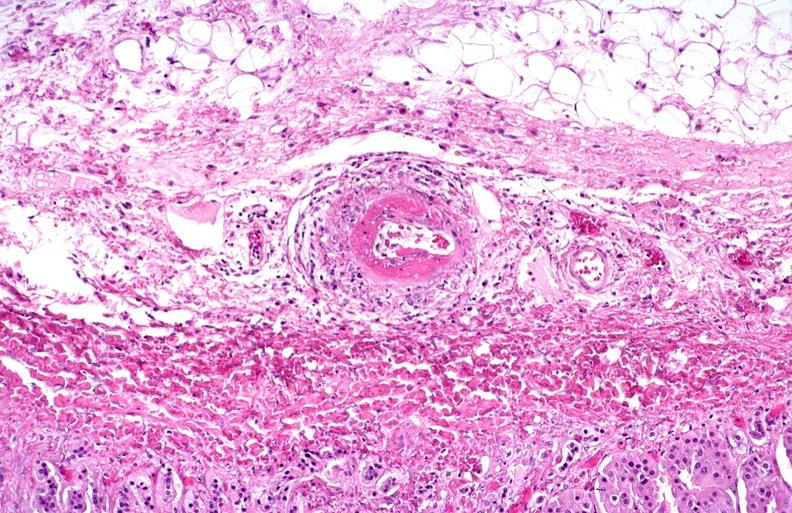does this image show polyarteritis nodosa?
Answer the question using a single word or phrase. Yes 